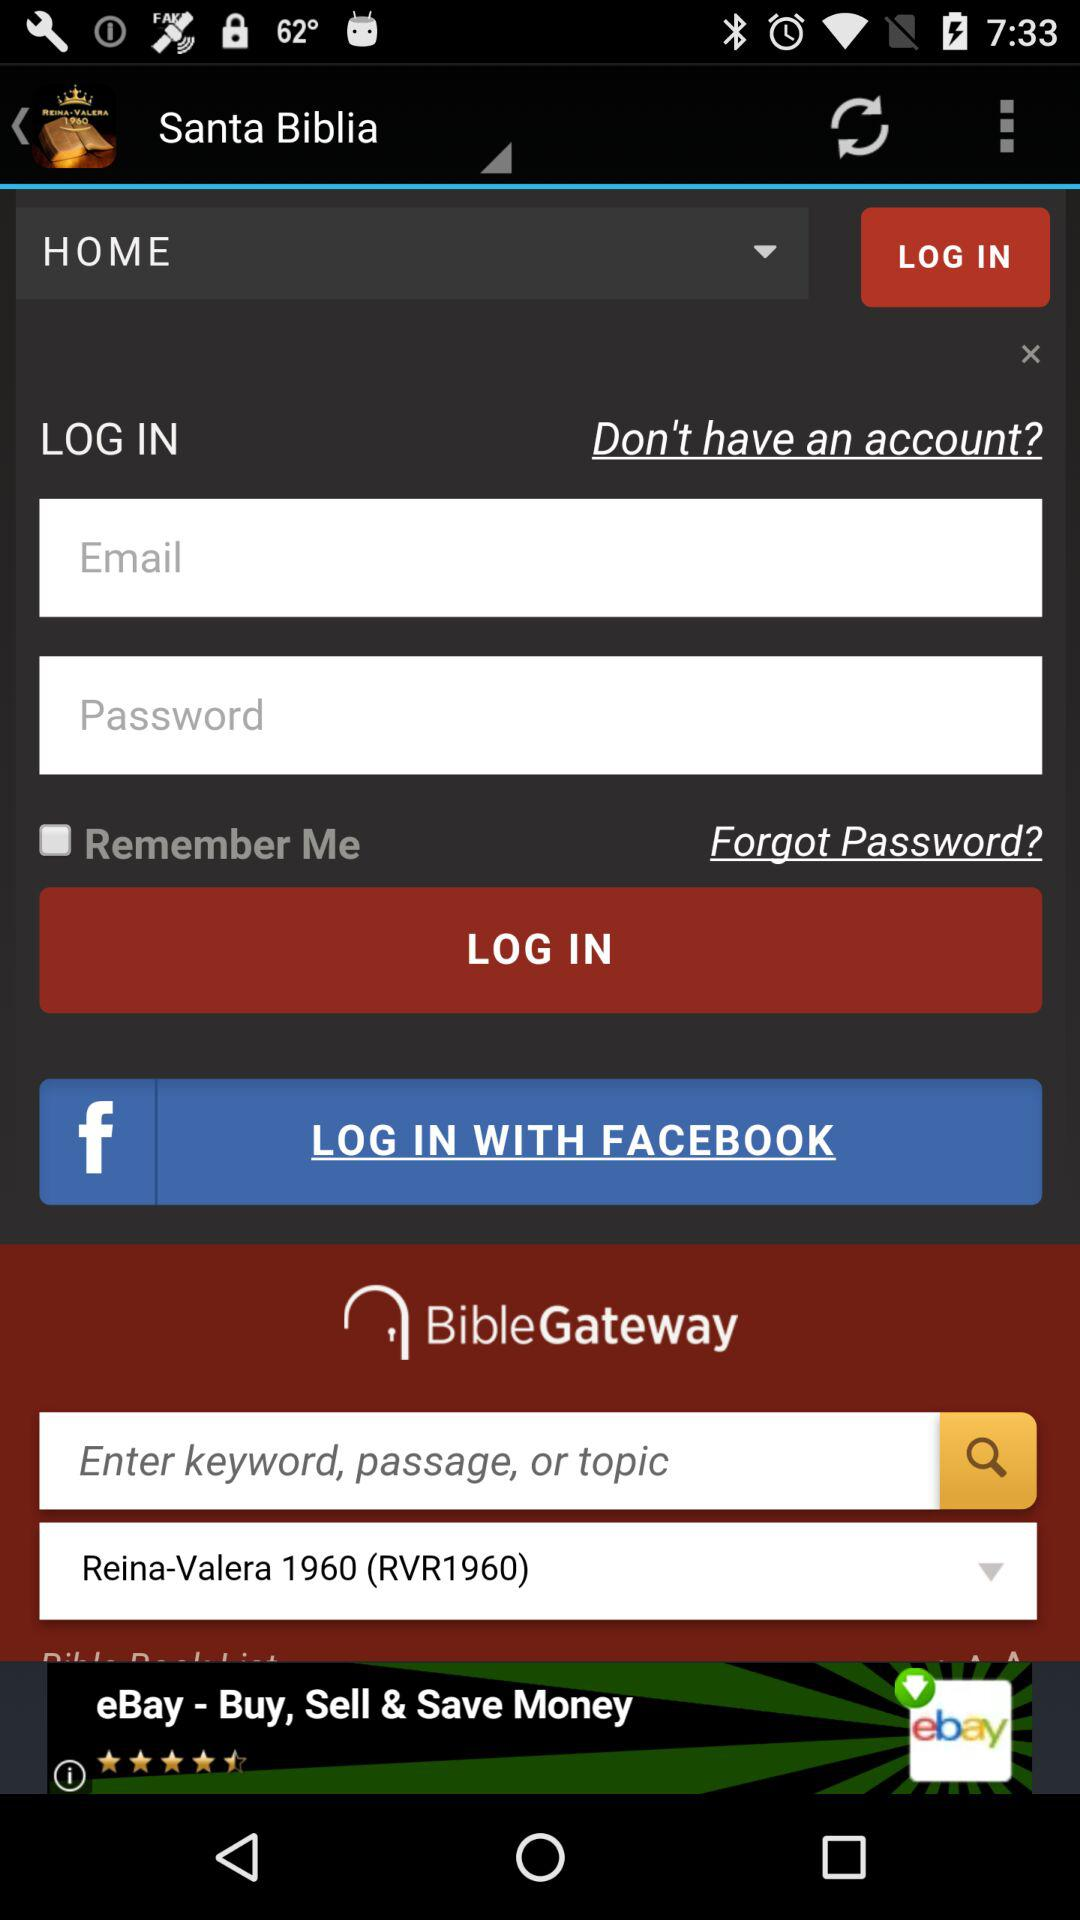By what application can we log in directly? You can log in directly with "FACEBOOK". 